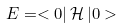Convert formula to latex. <formula><loc_0><loc_0><loc_500><loc_500>E = < 0 | \, \mathcal { H \, } | 0 ></formula> 